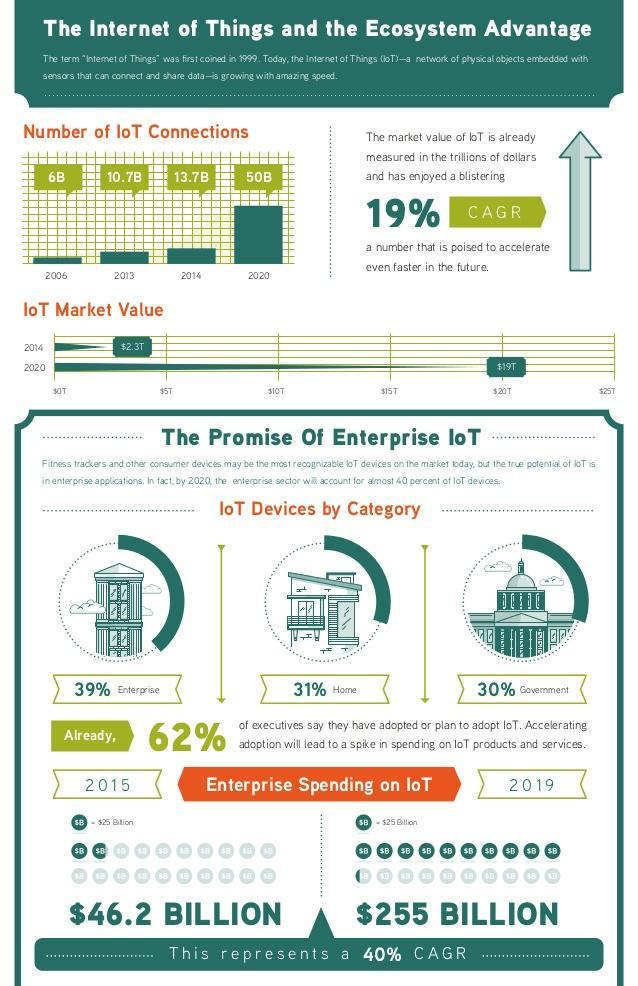Which sector accounts for almost 30% of the IoT devices?
Answer the question with a short phrase. Government What is the enterprise spending on IoT in 2019? $255 BILLION What is the number of IoT connections in 2020? 50B How much is the IoT market value in 2014? $2.3T What is the number of IoT connections in 2006? 6B How much is the IoT market value in 2020? $19T What is the enterprise spending on IoT in 2015? $46.2 BILLION Which year the number of IoT connections reached 13.7 billion? 2014 Which year the number of IoT connections reached 10.7 billion? 2013 